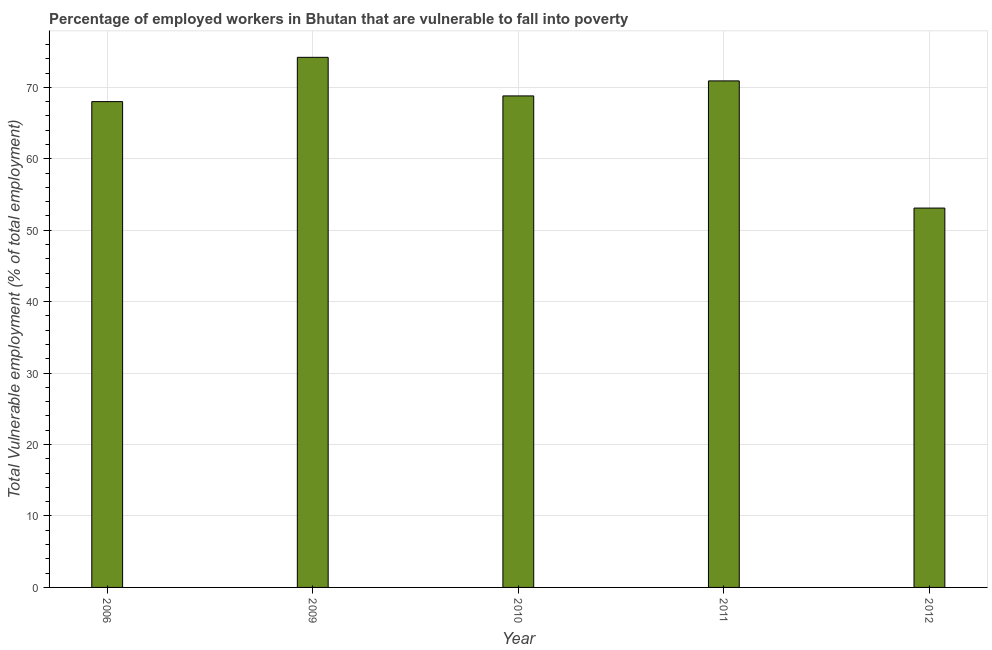Does the graph contain any zero values?
Offer a terse response. No. Does the graph contain grids?
Ensure brevity in your answer.  Yes. What is the title of the graph?
Give a very brief answer. Percentage of employed workers in Bhutan that are vulnerable to fall into poverty. What is the label or title of the Y-axis?
Offer a terse response. Total Vulnerable employment (% of total employment). Across all years, what is the maximum total vulnerable employment?
Your answer should be very brief. 74.2. Across all years, what is the minimum total vulnerable employment?
Keep it short and to the point. 53.1. In which year was the total vulnerable employment maximum?
Your response must be concise. 2009. In which year was the total vulnerable employment minimum?
Make the answer very short. 2012. What is the sum of the total vulnerable employment?
Make the answer very short. 335. What is the difference between the total vulnerable employment in 2006 and 2011?
Provide a succinct answer. -2.9. What is the median total vulnerable employment?
Offer a terse response. 68.8. In how many years, is the total vulnerable employment greater than 16 %?
Your response must be concise. 5. Is the total vulnerable employment in 2006 less than that in 2012?
Offer a very short reply. No. What is the difference between the highest and the second highest total vulnerable employment?
Your answer should be compact. 3.3. What is the difference between the highest and the lowest total vulnerable employment?
Offer a very short reply. 21.1. What is the difference between two consecutive major ticks on the Y-axis?
Keep it short and to the point. 10. What is the Total Vulnerable employment (% of total employment) in 2009?
Your answer should be very brief. 74.2. What is the Total Vulnerable employment (% of total employment) in 2010?
Make the answer very short. 68.8. What is the Total Vulnerable employment (% of total employment) in 2011?
Provide a short and direct response. 70.9. What is the Total Vulnerable employment (% of total employment) of 2012?
Your answer should be compact. 53.1. What is the difference between the Total Vulnerable employment (% of total employment) in 2006 and 2010?
Make the answer very short. -0.8. What is the difference between the Total Vulnerable employment (% of total employment) in 2009 and 2010?
Your answer should be compact. 5.4. What is the difference between the Total Vulnerable employment (% of total employment) in 2009 and 2011?
Your response must be concise. 3.3. What is the difference between the Total Vulnerable employment (% of total employment) in 2009 and 2012?
Your answer should be very brief. 21.1. What is the difference between the Total Vulnerable employment (% of total employment) in 2010 and 2012?
Your answer should be very brief. 15.7. What is the ratio of the Total Vulnerable employment (% of total employment) in 2006 to that in 2009?
Offer a very short reply. 0.92. What is the ratio of the Total Vulnerable employment (% of total employment) in 2006 to that in 2012?
Make the answer very short. 1.28. What is the ratio of the Total Vulnerable employment (% of total employment) in 2009 to that in 2010?
Keep it short and to the point. 1.08. What is the ratio of the Total Vulnerable employment (% of total employment) in 2009 to that in 2011?
Offer a terse response. 1.05. What is the ratio of the Total Vulnerable employment (% of total employment) in 2009 to that in 2012?
Provide a succinct answer. 1.4. What is the ratio of the Total Vulnerable employment (% of total employment) in 2010 to that in 2011?
Keep it short and to the point. 0.97. What is the ratio of the Total Vulnerable employment (% of total employment) in 2010 to that in 2012?
Your response must be concise. 1.3. What is the ratio of the Total Vulnerable employment (% of total employment) in 2011 to that in 2012?
Your answer should be very brief. 1.33. 